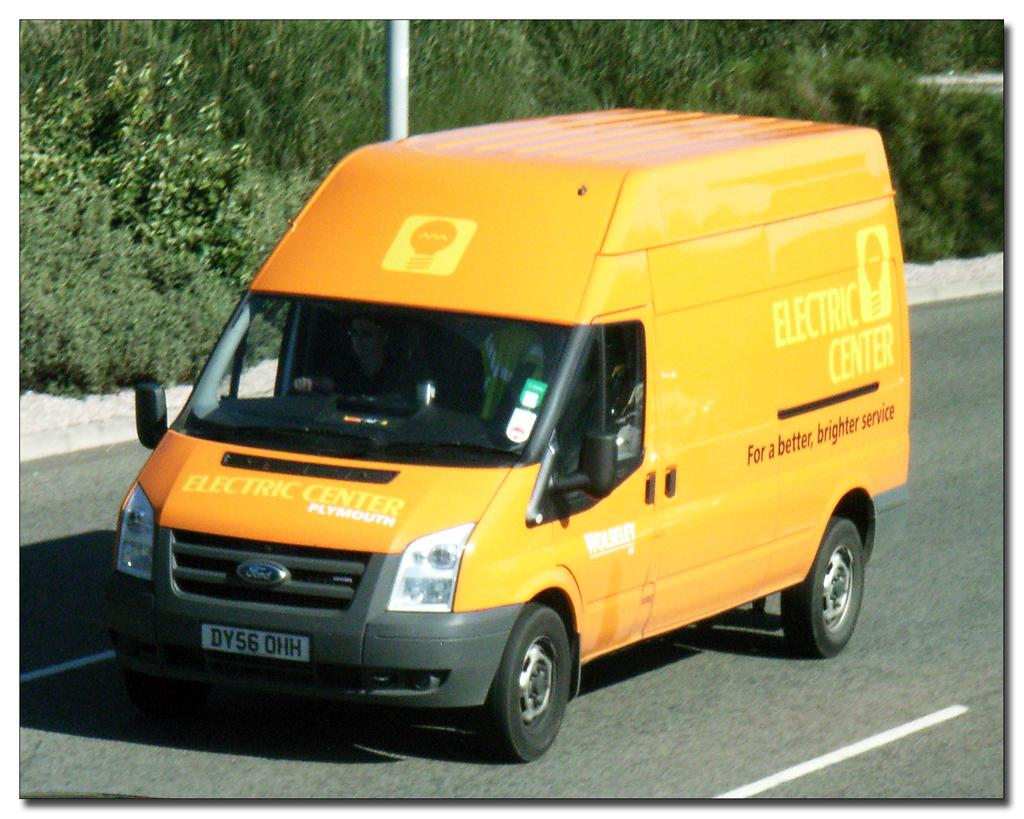<image>
Describe the image concisely. the word electric is on a big yellow van 